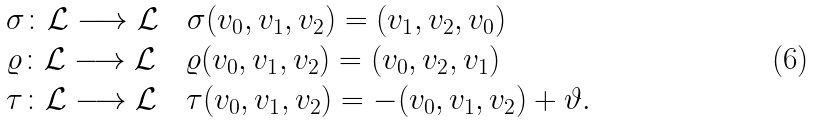<formula> <loc_0><loc_0><loc_500><loc_500>\begin{array} { l } \sigma \colon { \mathcal { L } } \longrightarrow { \mathcal { L } } \quad \sigma ( v _ { 0 } , v _ { 1 } , v _ { 2 } ) = ( v _ { 1 } , v _ { 2 } , v _ { 0 } ) \\ \varrho \colon { \mathcal { L } } \longrightarrow { \mathcal { L } } \quad \varrho ( v _ { 0 } , v _ { 1 } , v _ { 2 } ) = ( v _ { 0 } , v _ { 2 } , v _ { 1 } ) \\ \tau \colon { \mathcal { L } } \longrightarrow { \mathcal { L } } \quad \tau ( v _ { 0 } , v _ { 1 } , v _ { 2 } ) = - ( v _ { 0 } , v _ { 1 } , v _ { 2 } ) + \vartheta . \end{array}</formula> 